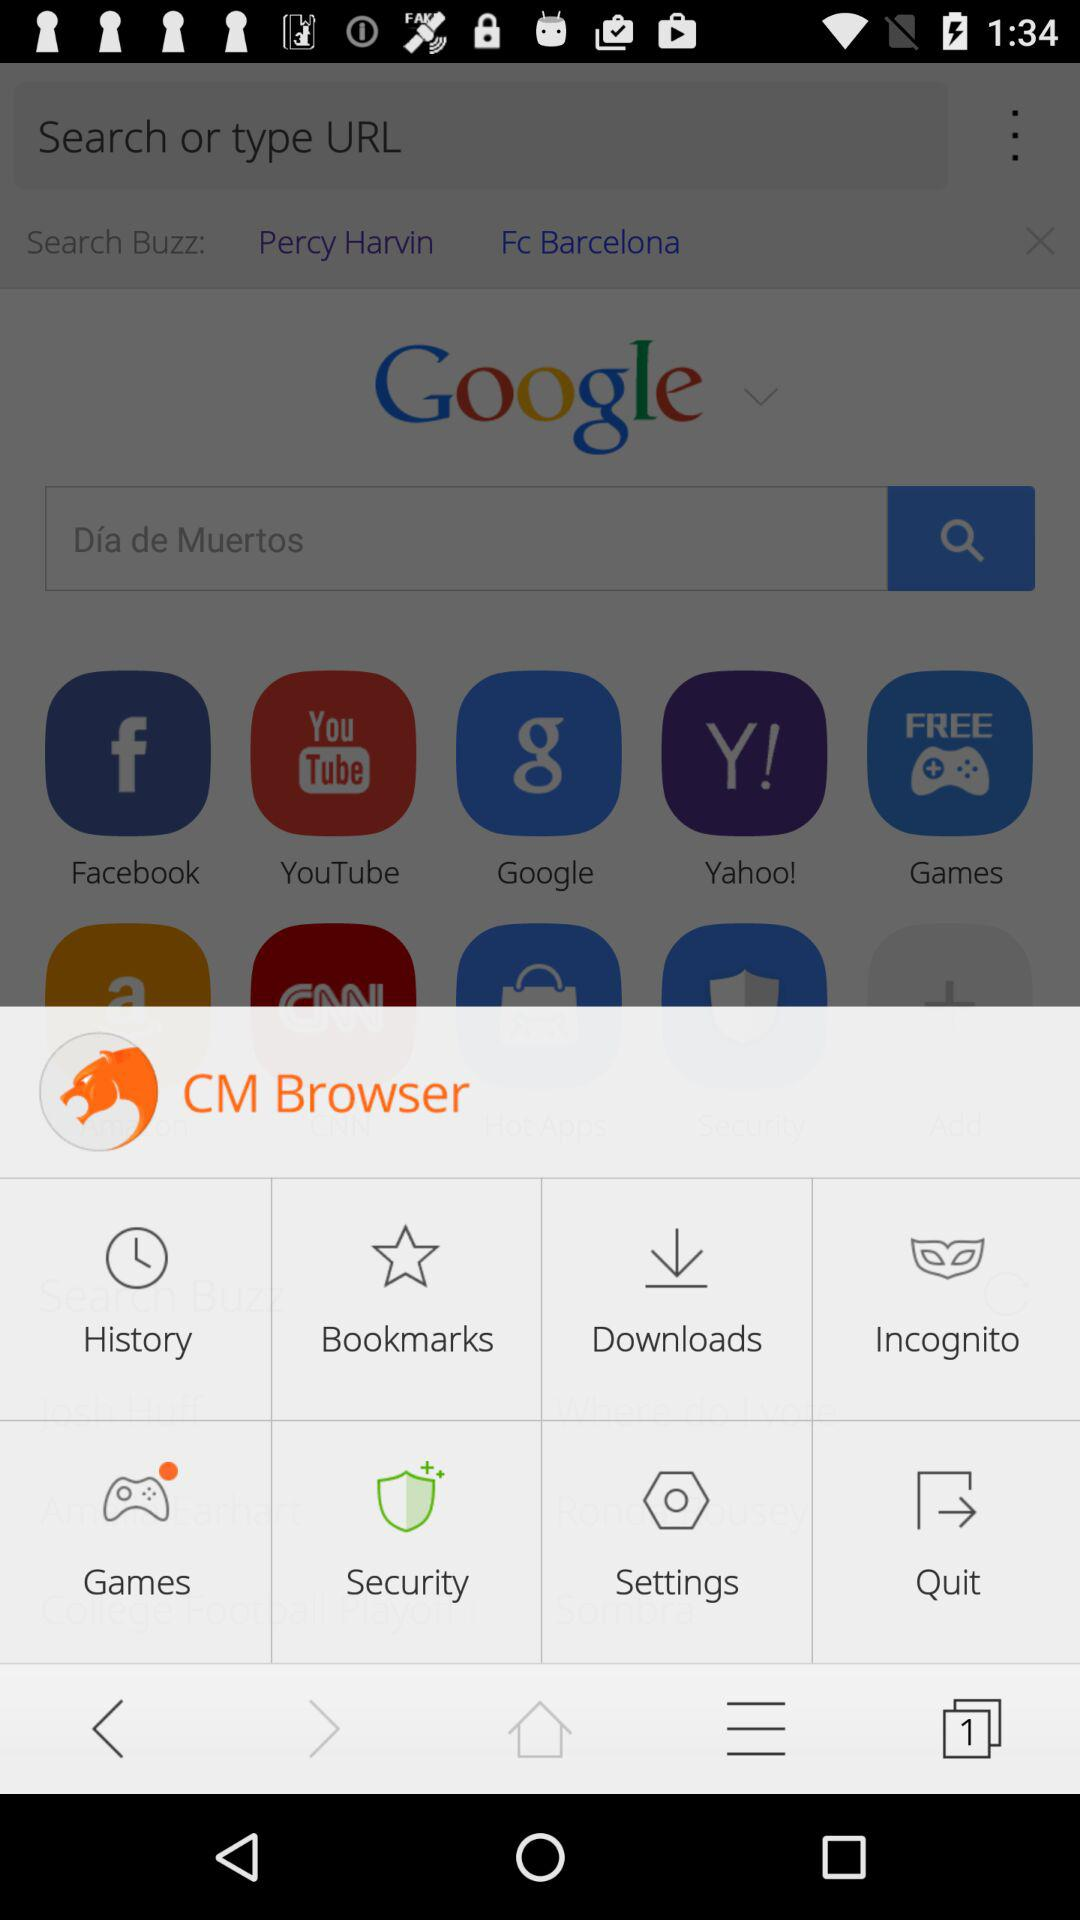What is the application name? The application name is "CM Browser". 